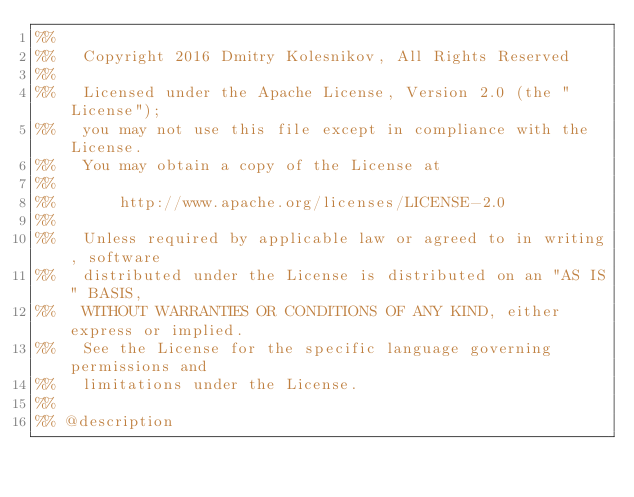Convert code to text. <code><loc_0><loc_0><loc_500><loc_500><_Erlang_>%%
%%   Copyright 2016 Dmitry Kolesnikov, All Rights Reserved
%%
%%   Licensed under the Apache License, Version 2.0 (the "License");
%%   you may not use this file except in compliance with the License.
%%   You may obtain a copy of the License at
%%
%%       http://www.apache.org/licenses/LICENSE-2.0
%%
%%   Unless required by applicable law or agreed to in writing, software
%%   distributed under the License is distributed on an "AS IS" BASIS,
%%   WITHOUT WARRANTIES OR CONDITIONS OF ANY KIND, either express or implied.
%%   See the License for the specific language governing permissions and
%%   limitations under the License.
%%
%% @description</code> 